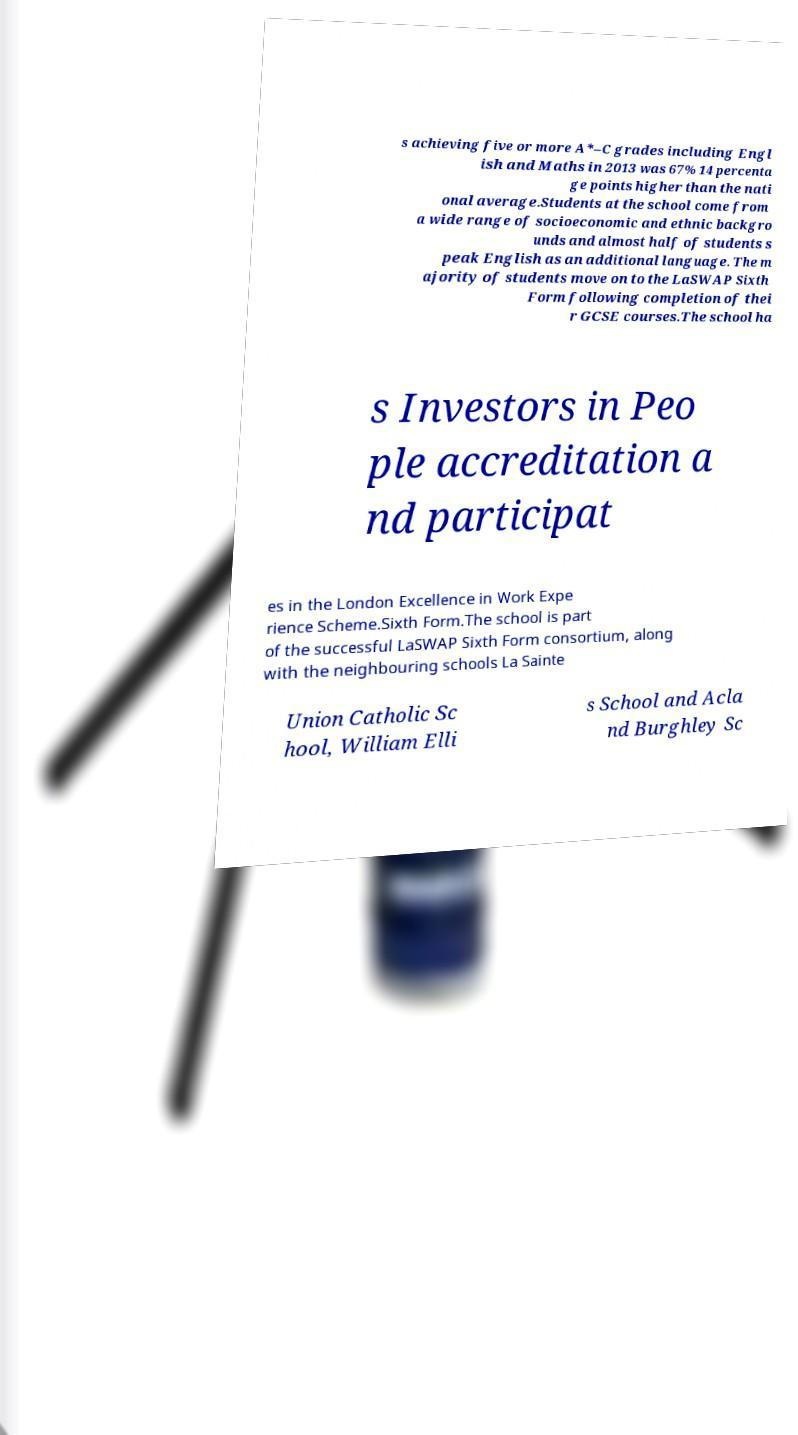Could you extract and type out the text from this image? s achieving five or more A*–C grades including Engl ish and Maths in 2013 was 67% 14 percenta ge points higher than the nati onal average.Students at the school come from a wide range of socioeconomic and ethnic backgro unds and almost half of students s peak English as an additional language. The m ajority of students move on to the LaSWAP Sixth Form following completion of thei r GCSE courses.The school ha s Investors in Peo ple accreditation a nd participat es in the London Excellence in Work Expe rience Scheme.Sixth Form.The school is part of the successful LaSWAP Sixth Form consortium, along with the neighbouring schools La Sainte Union Catholic Sc hool, William Elli s School and Acla nd Burghley Sc 